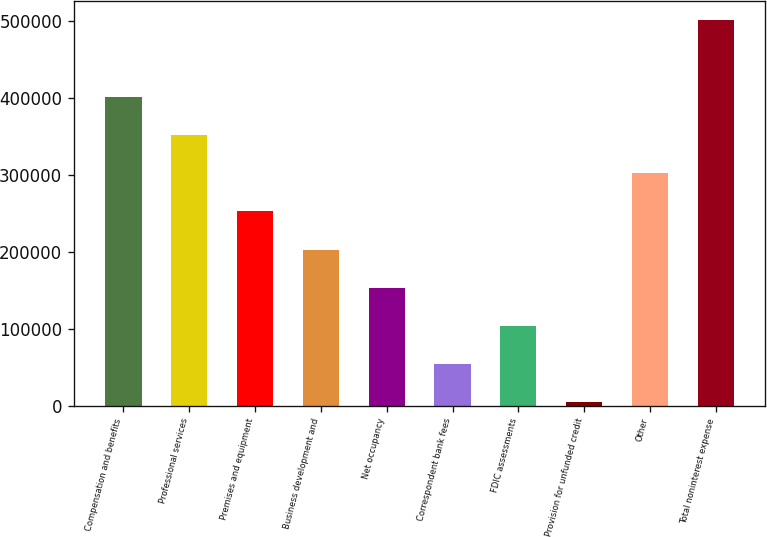<chart> <loc_0><loc_0><loc_500><loc_500><bar_chart><fcel>Compensation and benefits<fcel>Professional services<fcel>Premises and equipment<fcel>Business development and<fcel>Net occupancy<fcel>Correspondent bank fees<fcel>FDIC assessments<fcel>Provision for unfunded credit<fcel>Other<fcel>Total noninterest expense<nl><fcel>401382<fcel>351759<fcel>252512<fcel>202889<fcel>153266<fcel>54020.1<fcel>103643<fcel>4397<fcel>302136<fcel>500628<nl></chart> 